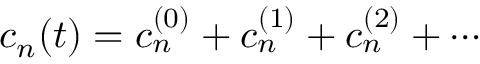<formula> <loc_0><loc_0><loc_500><loc_500>c _ { n } ( t ) = c _ { n } ^ { ( 0 ) } + c _ { n } ^ { ( 1 ) } + c _ { n } ^ { ( 2 ) } + \cdots</formula> 